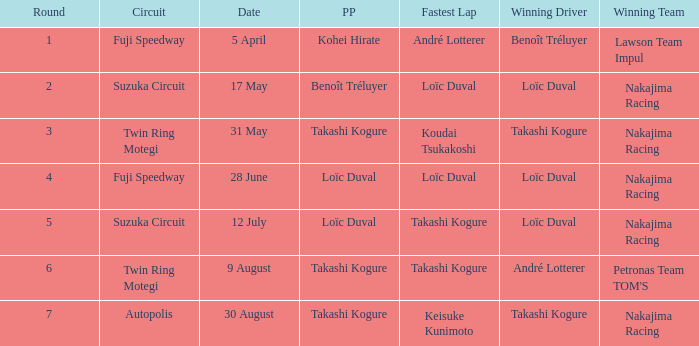What was the earlier round where Takashi Kogure got the fastest lap? 5.0. 